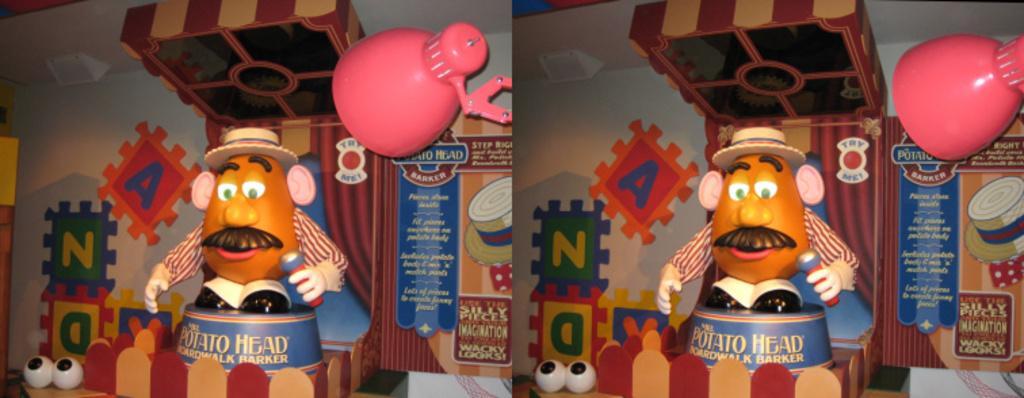In one or two sentences, can you explain what this image depicts? In this image on the right side and left side there are two toys, and in the background there are some posters stick to the wall. And on the right side and in the center there are two lights, on the top of the image there are two boxes. And at the bottom there are some toys and in the background there is a wall. 